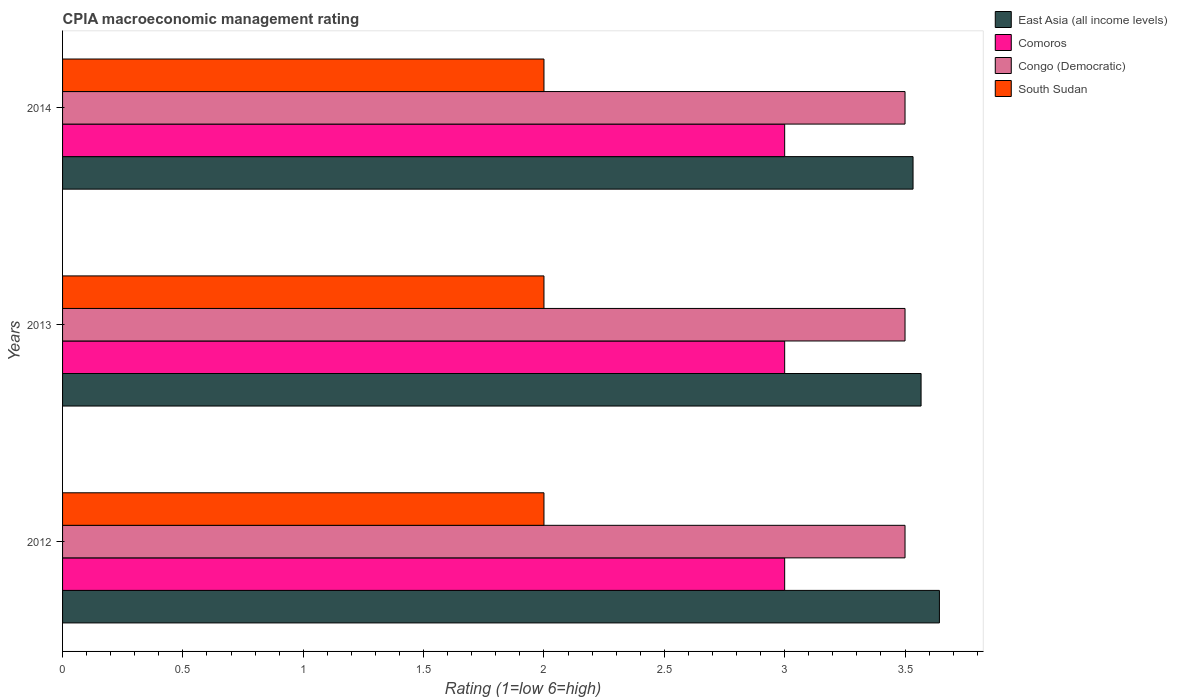How many different coloured bars are there?
Your response must be concise. 4. How many groups of bars are there?
Your answer should be very brief. 3. How many bars are there on the 3rd tick from the top?
Your answer should be very brief. 4. How many bars are there on the 1st tick from the bottom?
Offer a very short reply. 4. Across all years, what is the maximum CPIA rating in South Sudan?
Give a very brief answer. 2. Across all years, what is the minimum CPIA rating in East Asia (all income levels)?
Ensure brevity in your answer.  3.53. In which year was the CPIA rating in South Sudan maximum?
Offer a terse response. 2012. In which year was the CPIA rating in Congo (Democratic) minimum?
Provide a succinct answer. 2012. What is the difference between the CPIA rating in Congo (Democratic) in 2012 and that in 2013?
Give a very brief answer. 0. What is the difference between the CPIA rating in East Asia (all income levels) in 2013 and the CPIA rating in Congo (Democratic) in 2012?
Provide a short and direct response. 0.07. What is the average CPIA rating in East Asia (all income levels) per year?
Offer a very short reply. 3.58. In the year 2014, what is the difference between the CPIA rating in Comoros and CPIA rating in South Sudan?
Your answer should be very brief. 1. In how many years, is the CPIA rating in South Sudan greater than 2.7 ?
Offer a very short reply. 0. What is the ratio of the CPIA rating in South Sudan in 2012 to that in 2013?
Give a very brief answer. 1. Is the CPIA rating in East Asia (all income levels) in 2012 less than that in 2014?
Keep it short and to the point. No. What is the difference between the highest and the second highest CPIA rating in Congo (Democratic)?
Provide a short and direct response. 0. What is the difference between the highest and the lowest CPIA rating in South Sudan?
Make the answer very short. 0. In how many years, is the CPIA rating in South Sudan greater than the average CPIA rating in South Sudan taken over all years?
Keep it short and to the point. 0. Is it the case that in every year, the sum of the CPIA rating in East Asia (all income levels) and CPIA rating in Comoros is greater than the sum of CPIA rating in Congo (Democratic) and CPIA rating in South Sudan?
Your answer should be compact. Yes. What does the 2nd bar from the top in 2013 represents?
Provide a succinct answer. Congo (Democratic). What does the 4th bar from the bottom in 2012 represents?
Keep it short and to the point. South Sudan. How many bars are there?
Your response must be concise. 12. How many years are there in the graph?
Your answer should be very brief. 3. What is the difference between two consecutive major ticks on the X-axis?
Offer a terse response. 0.5. Are the values on the major ticks of X-axis written in scientific E-notation?
Your response must be concise. No. How many legend labels are there?
Provide a short and direct response. 4. How are the legend labels stacked?
Give a very brief answer. Vertical. What is the title of the graph?
Your answer should be compact. CPIA macroeconomic management rating. What is the label or title of the X-axis?
Offer a terse response. Rating (1=low 6=high). What is the Rating (1=low 6=high) in East Asia (all income levels) in 2012?
Offer a very short reply. 3.64. What is the Rating (1=low 6=high) of East Asia (all income levels) in 2013?
Make the answer very short. 3.57. What is the Rating (1=low 6=high) of East Asia (all income levels) in 2014?
Give a very brief answer. 3.53. What is the Rating (1=low 6=high) of Comoros in 2014?
Your answer should be compact. 3. Across all years, what is the maximum Rating (1=low 6=high) of East Asia (all income levels)?
Your answer should be compact. 3.64. Across all years, what is the maximum Rating (1=low 6=high) of South Sudan?
Make the answer very short. 2. Across all years, what is the minimum Rating (1=low 6=high) of East Asia (all income levels)?
Ensure brevity in your answer.  3.53. Across all years, what is the minimum Rating (1=low 6=high) of Comoros?
Provide a short and direct response. 3. Across all years, what is the minimum Rating (1=low 6=high) in Congo (Democratic)?
Offer a terse response. 3.5. Across all years, what is the minimum Rating (1=low 6=high) in South Sudan?
Give a very brief answer. 2. What is the total Rating (1=low 6=high) of East Asia (all income levels) in the graph?
Offer a terse response. 10.74. What is the total Rating (1=low 6=high) in Comoros in the graph?
Your answer should be compact. 9. What is the total Rating (1=low 6=high) in South Sudan in the graph?
Offer a terse response. 6. What is the difference between the Rating (1=low 6=high) in East Asia (all income levels) in 2012 and that in 2013?
Offer a very short reply. 0.08. What is the difference between the Rating (1=low 6=high) in Comoros in 2012 and that in 2013?
Give a very brief answer. 0. What is the difference between the Rating (1=low 6=high) of South Sudan in 2012 and that in 2013?
Ensure brevity in your answer.  0. What is the difference between the Rating (1=low 6=high) of East Asia (all income levels) in 2012 and that in 2014?
Keep it short and to the point. 0.11. What is the difference between the Rating (1=low 6=high) in Congo (Democratic) in 2012 and that in 2014?
Offer a terse response. 0. What is the difference between the Rating (1=low 6=high) of East Asia (all income levels) in 2013 and that in 2014?
Keep it short and to the point. 0.03. What is the difference between the Rating (1=low 6=high) of Congo (Democratic) in 2013 and that in 2014?
Make the answer very short. 0. What is the difference between the Rating (1=low 6=high) of East Asia (all income levels) in 2012 and the Rating (1=low 6=high) of Comoros in 2013?
Ensure brevity in your answer.  0.64. What is the difference between the Rating (1=low 6=high) in East Asia (all income levels) in 2012 and the Rating (1=low 6=high) in Congo (Democratic) in 2013?
Your answer should be very brief. 0.14. What is the difference between the Rating (1=low 6=high) in East Asia (all income levels) in 2012 and the Rating (1=low 6=high) in South Sudan in 2013?
Offer a terse response. 1.64. What is the difference between the Rating (1=low 6=high) of Congo (Democratic) in 2012 and the Rating (1=low 6=high) of South Sudan in 2013?
Give a very brief answer. 1.5. What is the difference between the Rating (1=low 6=high) in East Asia (all income levels) in 2012 and the Rating (1=low 6=high) in Comoros in 2014?
Your answer should be compact. 0.64. What is the difference between the Rating (1=low 6=high) of East Asia (all income levels) in 2012 and the Rating (1=low 6=high) of Congo (Democratic) in 2014?
Your answer should be compact. 0.14. What is the difference between the Rating (1=low 6=high) in East Asia (all income levels) in 2012 and the Rating (1=low 6=high) in South Sudan in 2014?
Provide a short and direct response. 1.64. What is the difference between the Rating (1=low 6=high) in Comoros in 2012 and the Rating (1=low 6=high) in Congo (Democratic) in 2014?
Your answer should be very brief. -0.5. What is the difference between the Rating (1=low 6=high) in East Asia (all income levels) in 2013 and the Rating (1=low 6=high) in Comoros in 2014?
Keep it short and to the point. 0.57. What is the difference between the Rating (1=low 6=high) in East Asia (all income levels) in 2013 and the Rating (1=low 6=high) in Congo (Democratic) in 2014?
Give a very brief answer. 0.07. What is the difference between the Rating (1=low 6=high) in East Asia (all income levels) in 2013 and the Rating (1=low 6=high) in South Sudan in 2014?
Make the answer very short. 1.57. What is the difference between the Rating (1=low 6=high) of Comoros in 2013 and the Rating (1=low 6=high) of South Sudan in 2014?
Provide a short and direct response. 1. What is the average Rating (1=low 6=high) of East Asia (all income levels) per year?
Your answer should be compact. 3.58. What is the average Rating (1=low 6=high) in South Sudan per year?
Offer a very short reply. 2. In the year 2012, what is the difference between the Rating (1=low 6=high) of East Asia (all income levels) and Rating (1=low 6=high) of Comoros?
Ensure brevity in your answer.  0.64. In the year 2012, what is the difference between the Rating (1=low 6=high) of East Asia (all income levels) and Rating (1=low 6=high) of Congo (Democratic)?
Make the answer very short. 0.14. In the year 2012, what is the difference between the Rating (1=low 6=high) in East Asia (all income levels) and Rating (1=low 6=high) in South Sudan?
Give a very brief answer. 1.64. In the year 2012, what is the difference between the Rating (1=low 6=high) of Comoros and Rating (1=low 6=high) of South Sudan?
Ensure brevity in your answer.  1. In the year 2012, what is the difference between the Rating (1=low 6=high) of Congo (Democratic) and Rating (1=low 6=high) of South Sudan?
Your response must be concise. 1.5. In the year 2013, what is the difference between the Rating (1=low 6=high) of East Asia (all income levels) and Rating (1=low 6=high) of Comoros?
Make the answer very short. 0.57. In the year 2013, what is the difference between the Rating (1=low 6=high) in East Asia (all income levels) and Rating (1=low 6=high) in Congo (Democratic)?
Give a very brief answer. 0.07. In the year 2013, what is the difference between the Rating (1=low 6=high) of East Asia (all income levels) and Rating (1=low 6=high) of South Sudan?
Give a very brief answer. 1.57. In the year 2013, what is the difference between the Rating (1=low 6=high) of Comoros and Rating (1=low 6=high) of Congo (Democratic)?
Your response must be concise. -0.5. In the year 2013, what is the difference between the Rating (1=low 6=high) of Comoros and Rating (1=low 6=high) of South Sudan?
Provide a succinct answer. 1. In the year 2014, what is the difference between the Rating (1=low 6=high) of East Asia (all income levels) and Rating (1=low 6=high) of Comoros?
Give a very brief answer. 0.53. In the year 2014, what is the difference between the Rating (1=low 6=high) of East Asia (all income levels) and Rating (1=low 6=high) of South Sudan?
Keep it short and to the point. 1.53. In the year 2014, what is the difference between the Rating (1=low 6=high) in Comoros and Rating (1=low 6=high) in South Sudan?
Ensure brevity in your answer.  1. What is the ratio of the Rating (1=low 6=high) in East Asia (all income levels) in 2012 to that in 2013?
Ensure brevity in your answer.  1.02. What is the ratio of the Rating (1=low 6=high) of Comoros in 2012 to that in 2013?
Give a very brief answer. 1. What is the ratio of the Rating (1=low 6=high) of South Sudan in 2012 to that in 2013?
Provide a short and direct response. 1. What is the ratio of the Rating (1=low 6=high) of East Asia (all income levels) in 2012 to that in 2014?
Make the answer very short. 1.03. What is the ratio of the Rating (1=low 6=high) of East Asia (all income levels) in 2013 to that in 2014?
Provide a succinct answer. 1.01. What is the ratio of the Rating (1=low 6=high) of Comoros in 2013 to that in 2014?
Provide a succinct answer. 1. What is the ratio of the Rating (1=low 6=high) of Congo (Democratic) in 2013 to that in 2014?
Offer a terse response. 1. What is the difference between the highest and the second highest Rating (1=low 6=high) of East Asia (all income levels)?
Ensure brevity in your answer.  0.08. What is the difference between the highest and the second highest Rating (1=low 6=high) of Comoros?
Offer a terse response. 0. What is the difference between the highest and the second highest Rating (1=low 6=high) in Congo (Democratic)?
Your answer should be compact. 0. What is the difference between the highest and the lowest Rating (1=low 6=high) of East Asia (all income levels)?
Keep it short and to the point. 0.11. What is the difference between the highest and the lowest Rating (1=low 6=high) of Comoros?
Offer a very short reply. 0. What is the difference between the highest and the lowest Rating (1=low 6=high) in South Sudan?
Offer a terse response. 0. 